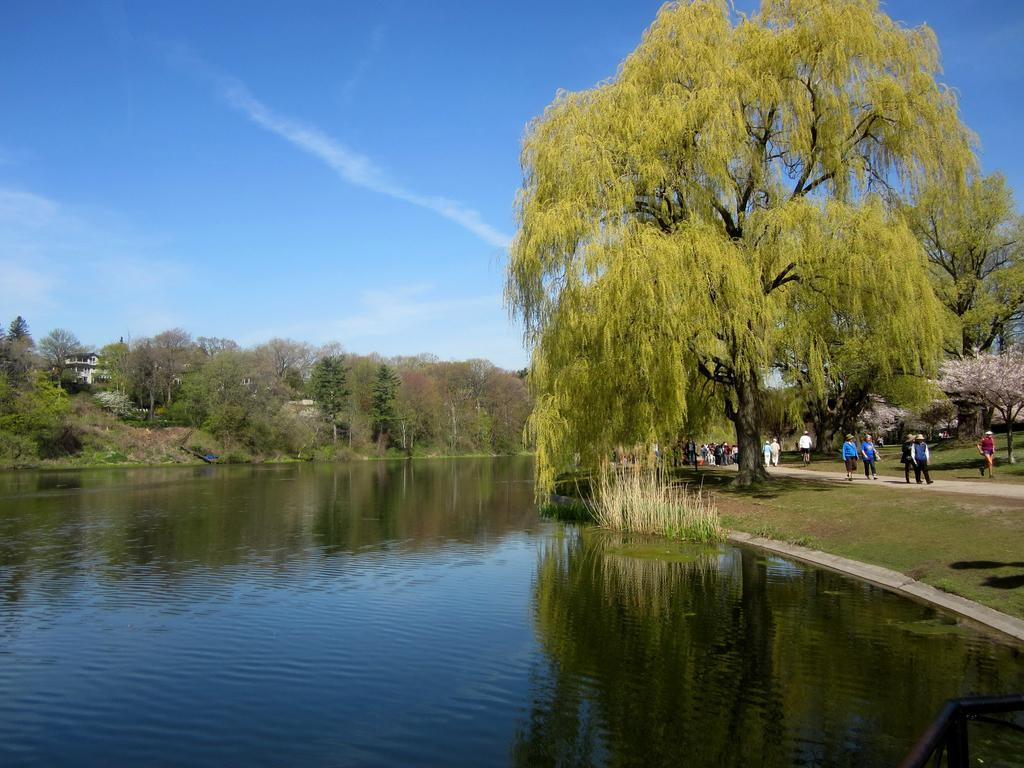What can be seen in the image that is liquid? There is water visible in the image. What type of vegetation is present in the image? There is grass in the image. What is the surface that the people are standing on? The ground is visible in the image. What type of pathway is in the image? There is a road in the image. How many people are visible in the image? There are people standing in the image. What other natural elements can be seen in the image? There are trees in the image. What is visible in the background of the image? There is a building and the sky in the background of the image. What type of sticks are being used by the people in the image? There are no sticks present in the image. What letters are being written by the people in the image? There is no indication that the people in the image are writing letters. What type of voyage are the people in the image embarking on? There is no indication of a voyage in the image. 